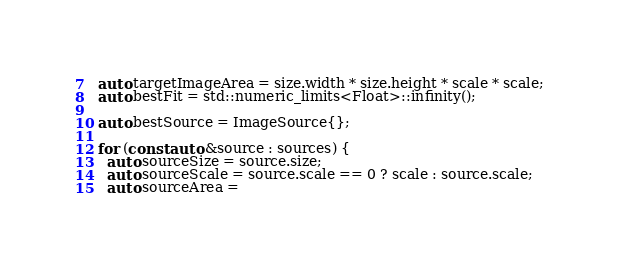Convert code to text. <code><loc_0><loc_0><loc_500><loc_500><_C++_>  auto targetImageArea = size.width * size.height * scale * scale;
  auto bestFit = std::numeric_limits<Float>::infinity();

  auto bestSource = ImageSource{};

  for (const auto &source : sources) {
    auto sourceSize = source.size;
    auto sourceScale = source.scale == 0 ? scale : source.scale;
    auto sourceArea =</code> 